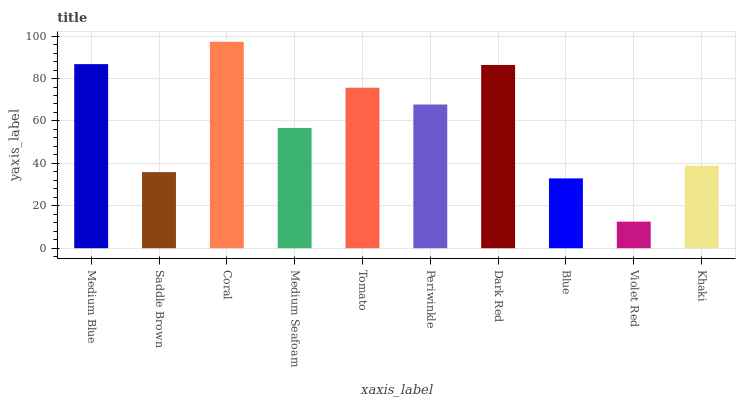Is Violet Red the minimum?
Answer yes or no. Yes. Is Coral the maximum?
Answer yes or no. Yes. Is Saddle Brown the minimum?
Answer yes or no. No. Is Saddle Brown the maximum?
Answer yes or no. No. Is Medium Blue greater than Saddle Brown?
Answer yes or no. Yes. Is Saddle Brown less than Medium Blue?
Answer yes or no. Yes. Is Saddle Brown greater than Medium Blue?
Answer yes or no. No. Is Medium Blue less than Saddle Brown?
Answer yes or no. No. Is Periwinkle the high median?
Answer yes or no. Yes. Is Medium Seafoam the low median?
Answer yes or no. Yes. Is Dark Red the high median?
Answer yes or no. No. Is Dark Red the low median?
Answer yes or no. No. 